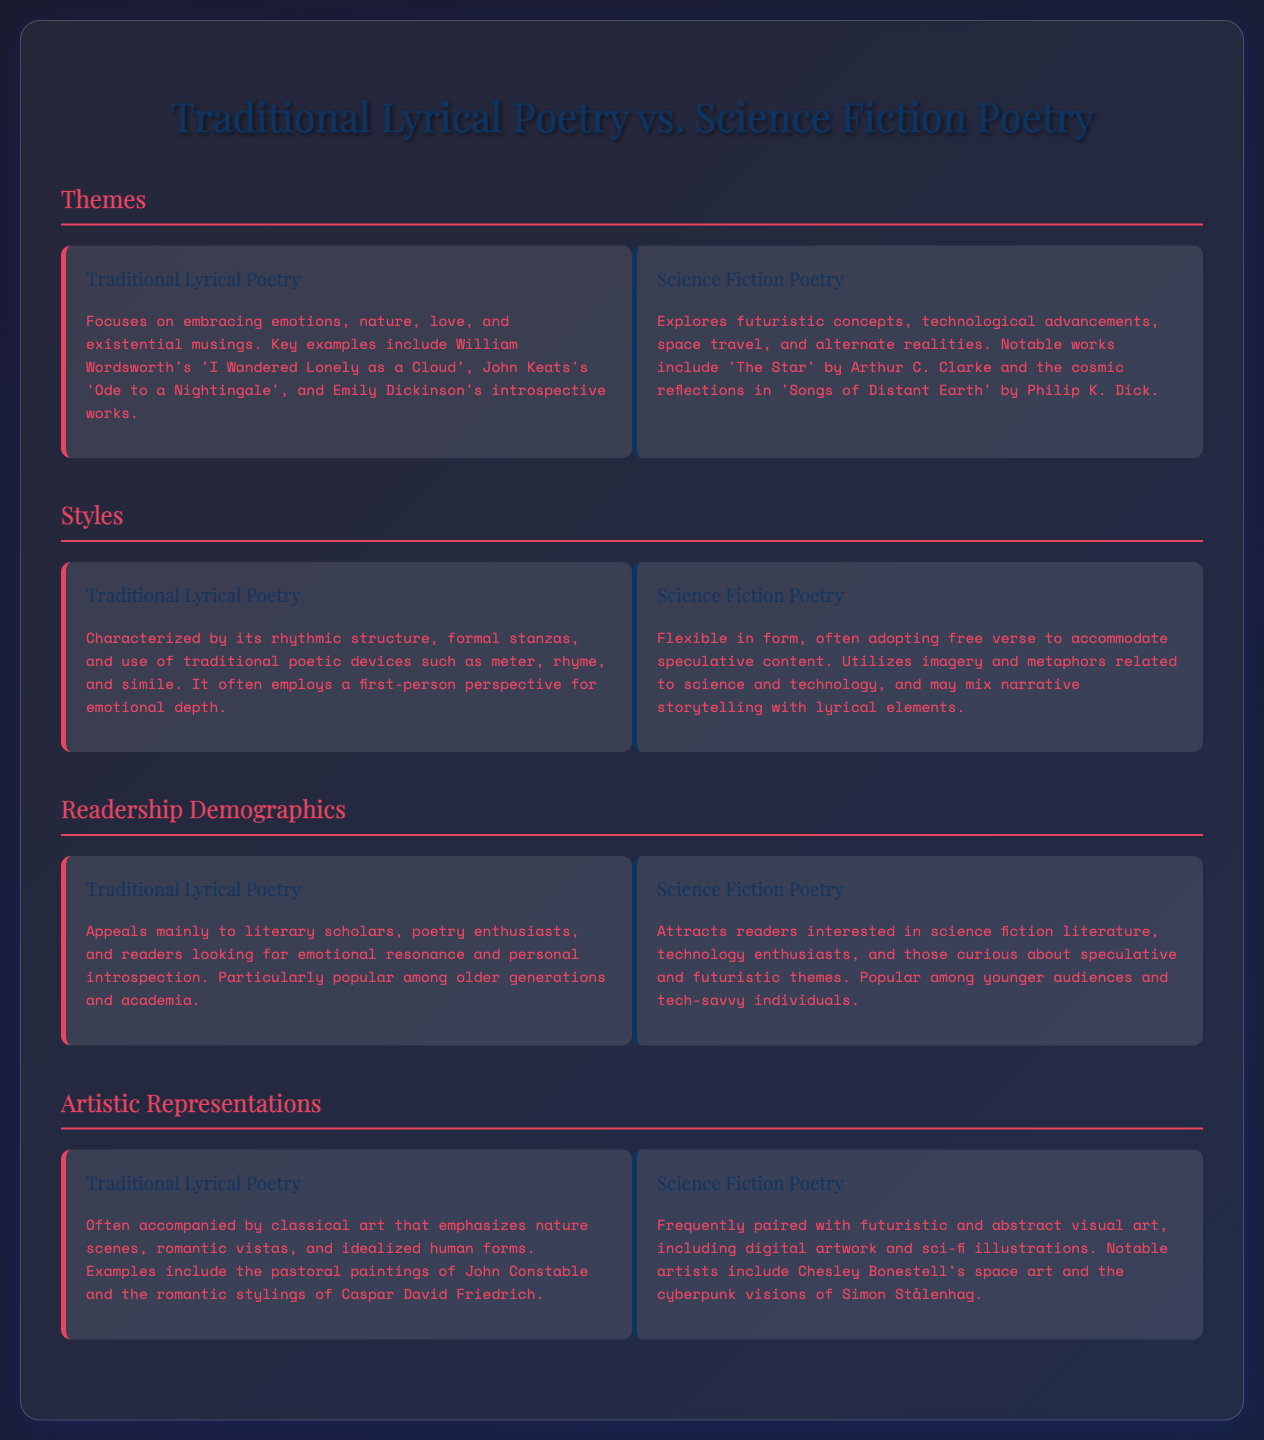What are key themes of Traditional Lyrical Poetry? The key themes include emotions, nature, love, and existential musings as stated in the document.
Answer: emotions, nature, love, existential musings What notable work is mentioned for Science Fiction Poetry? The document mentions 'The Star' by Arthur C. Clarke as a notable work in Science Fiction Poetry.
Answer: 'The Star' Which poetic devices are emphasized in Traditional Lyrical Poetry? Traditional Lyrical Poetry emphasizes meter, rhyme, and simile as mentioned in the document.
Answer: meter, rhyme, simile What type of readership primarily enjoys Traditional Lyrical Poetry? The document states that Traditional Lyrical Poetry appeals mainly to literary scholars, poetry enthusiasts, and readers looking for emotional resonance.
Answer: literary scholars, poetry enthusiasts What artistic representation is associated with Traditional Lyrical Poetry? Traditional Lyrical Poetry is often accompanied by classical art emphasizing nature scenes, romantic vistas, and idealized human forms.
Answer: classical art Which demographic is primarily drawn to Science Fiction Poetry? The document indicates that Science Fiction Poetry is popular among younger audiences and tech-savvy individuals.
Answer: younger audiences, tech-savvy individuals How does Science Fiction Poetry differ in its form from Traditional Lyrical Poetry? Science Fiction Poetry is flexible in form, often adopting free verse compared to the traditional structure of Traditional Lyrical Poetry.
Answer: free verse What kind of visuals accompany Science Fiction Poetry? Science Fiction Poetry is frequently paired with futuristic and abstract visual art.
Answer: futuristic and abstract visual art 